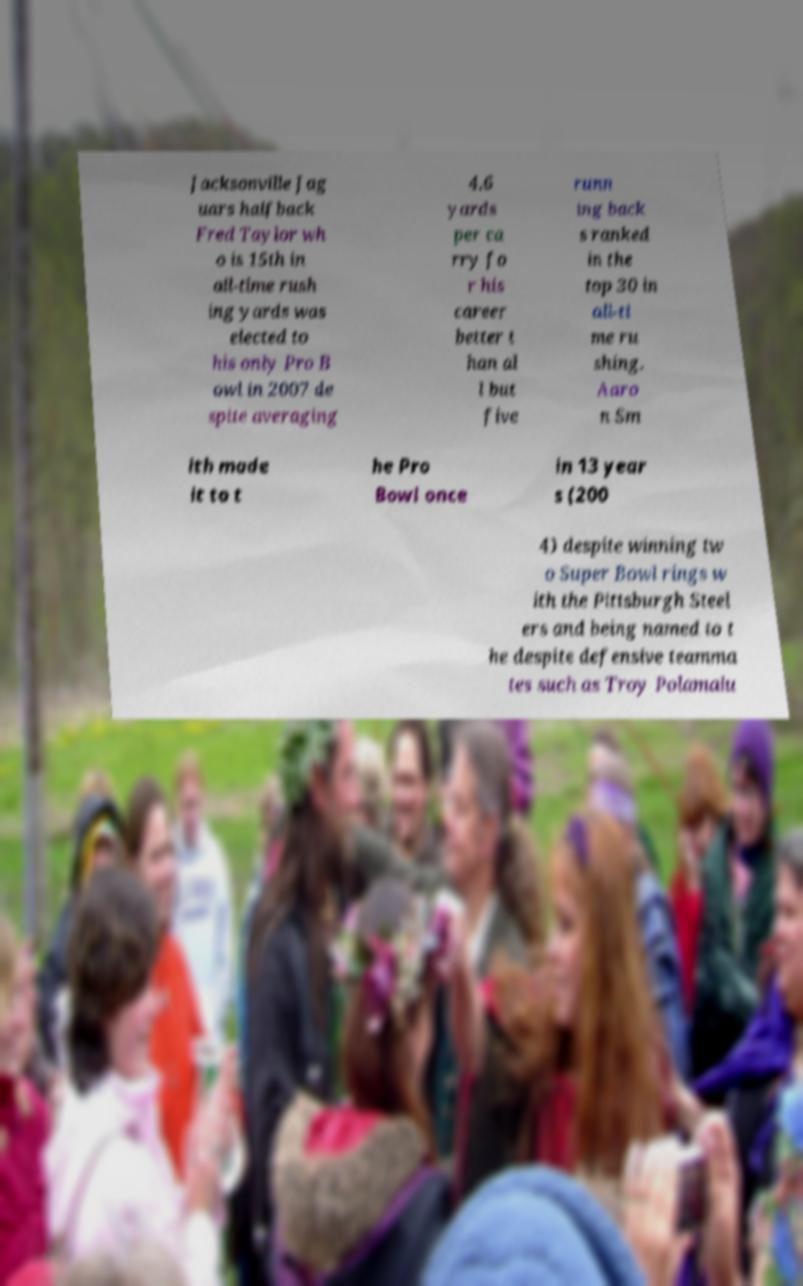Can you accurately transcribe the text from the provided image for me? Jacksonville Jag uars halfback Fred Taylor wh o is 15th in all-time rush ing yards was elected to his only Pro B owl in 2007 de spite averaging 4.6 yards per ca rry fo r his career better t han al l but five runn ing back s ranked in the top 30 in all-ti me ru shing. Aaro n Sm ith made it to t he Pro Bowl once in 13 year s (200 4) despite winning tw o Super Bowl rings w ith the Pittsburgh Steel ers and being named to t he despite defensive teamma tes such as Troy Polamalu 